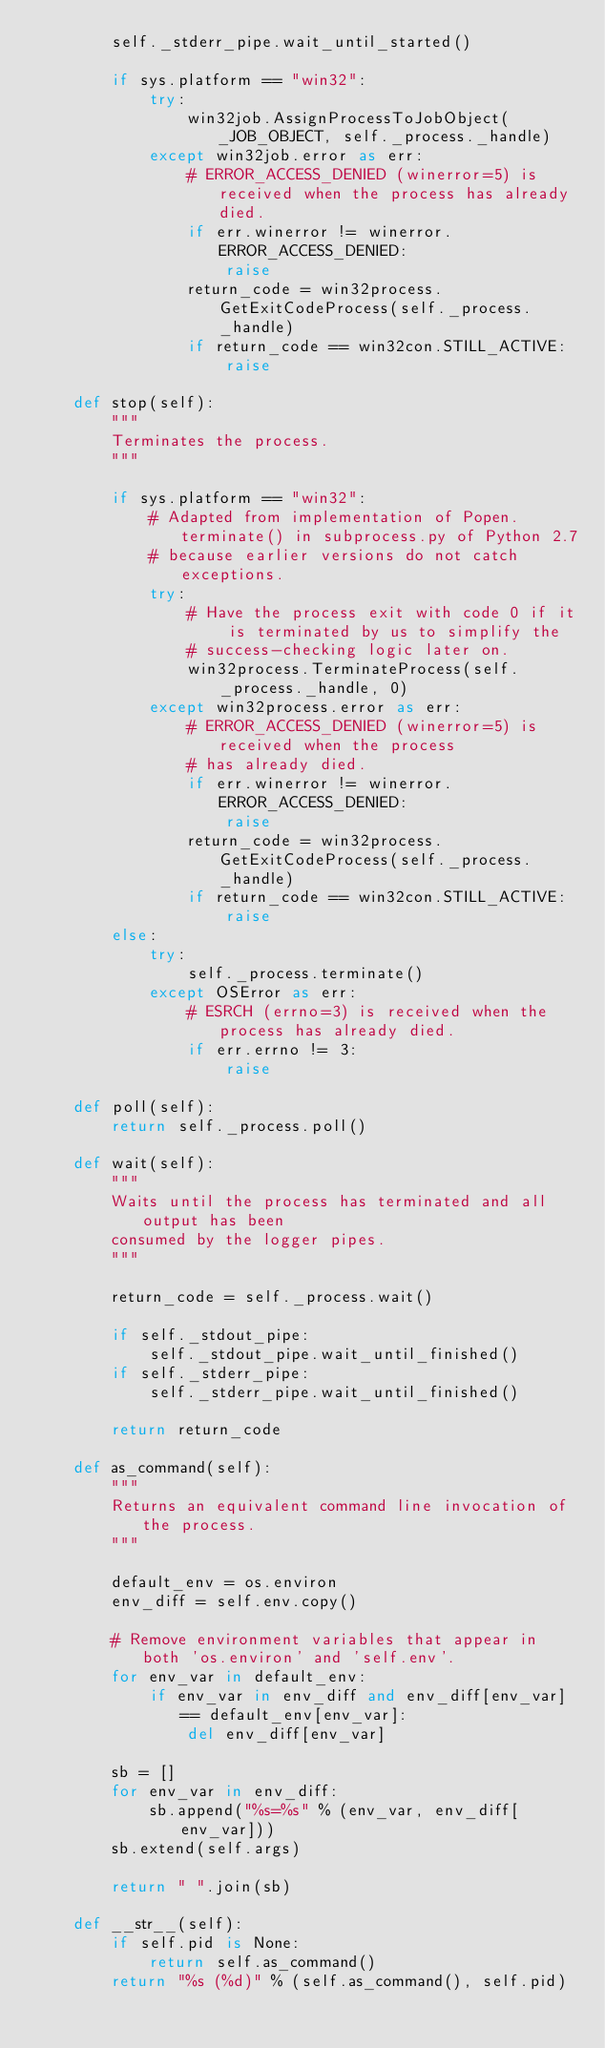<code> <loc_0><loc_0><loc_500><loc_500><_Python_>        self._stderr_pipe.wait_until_started()

        if sys.platform == "win32":
            try:
                win32job.AssignProcessToJobObject(_JOB_OBJECT, self._process._handle)
            except win32job.error as err:
                # ERROR_ACCESS_DENIED (winerror=5) is received when the process has already died.
                if err.winerror != winerror.ERROR_ACCESS_DENIED:
                    raise
                return_code = win32process.GetExitCodeProcess(self._process._handle)
                if return_code == win32con.STILL_ACTIVE:
                    raise

    def stop(self):
        """
        Terminates the process.
        """

        if sys.platform == "win32":
            # Adapted from implementation of Popen.terminate() in subprocess.py of Python 2.7
            # because earlier versions do not catch exceptions.
            try:
                # Have the process exit with code 0 if it is terminated by us to simplify the
                # success-checking logic later on.
                win32process.TerminateProcess(self._process._handle, 0)
            except win32process.error as err:
                # ERROR_ACCESS_DENIED (winerror=5) is received when the process
                # has already died.
                if err.winerror != winerror.ERROR_ACCESS_DENIED:
                    raise
                return_code = win32process.GetExitCodeProcess(self._process._handle)
                if return_code == win32con.STILL_ACTIVE:
                    raise
        else:
            try:
                self._process.terminate()
            except OSError as err:
                # ESRCH (errno=3) is received when the process has already died.
                if err.errno != 3:
                    raise

    def poll(self):
        return self._process.poll()

    def wait(self):
        """
        Waits until the process has terminated and all output has been
        consumed by the logger pipes.
        """

        return_code = self._process.wait()

        if self._stdout_pipe:
            self._stdout_pipe.wait_until_finished()
        if self._stderr_pipe:
            self._stderr_pipe.wait_until_finished()

        return return_code

    def as_command(self):
        """
        Returns an equivalent command line invocation of the process.
        """

        default_env = os.environ
        env_diff = self.env.copy()

        # Remove environment variables that appear in both 'os.environ' and 'self.env'.
        for env_var in default_env:
            if env_var in env_diff and env_diff[env_var] == default_env[env_var]:
                del env_diff[env_var]

        sb = []
        for env_var in env_diff:
            sb.append("%s=%s" % (env_var, env_diff[env_var]))
        sb.extend(self.args)

        return " ".join(sb)

    def __str__(self):
        if self.pid is None:
            return self.as_command()
        return "%s (%d)" % (self.as_command(), self.pid)
</code> 